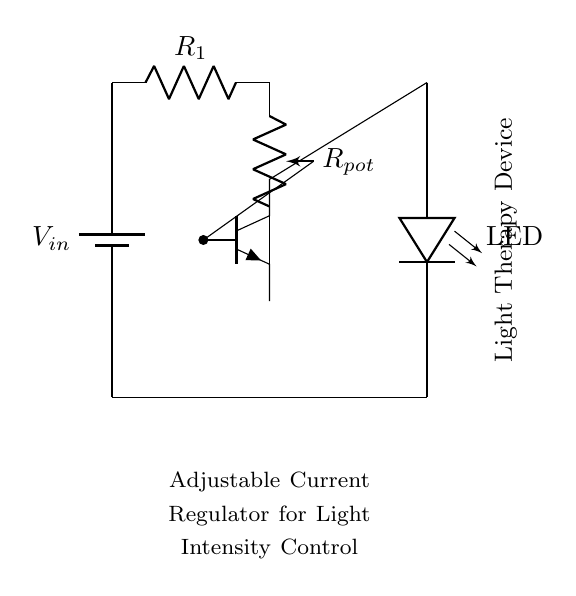What type of transistor is used in this circuit? The circuit diagram shows an NPN transistor, which is typically represented with three terminals labeled collector, base, and emitter. The orientation of the symbol indicates it is an NPN type.
Answer: NPN What does the potentiometer control? The potentiometer in this circuit adjusts the resistance, which in turn varies the current flowing to the transistor's base, allowing control over the light intensity output of the LED.
Answer: Current intensity What component is used for light output in this circuit? The circuit includes an LED as the light-emitting component, denoted in the diagram. LED stands for Light Emitting Diode and is placed in series for the light therapy application.
Answer: LED How many resistors are present in the circuit? There are two resistors in the circuit: one is a potentiometer and the other is a fixed resistor. The diagram's labeling indicates both components clearly.
Answer: Two resistors Why is the NPN transistor placed in this circuit? The NPN transistor functions as a switch or amplifier, allowing a small base current (controlled by the potentiometer) to control a larger current flowing through the LED, making it essential for current regulation in light therapy devices.
Answer: To regulate current What is the purpose of the variable resistor in this circuit? The variable resistor, or potentiometer, provides adjustable resistance, which allows for fine-tuning of the base current of the transistor. This adjustment directly influences the brightness of the LED.
Answer: Adjustable resistance What is the main function of the entire circuit? The circuit's main function is to serve as an adjustable current regulator for controlling the intensity of light therapy devices, ensuring the proper amount of current flows to the LED for therapeutic applications.
Answer: Current regulation 